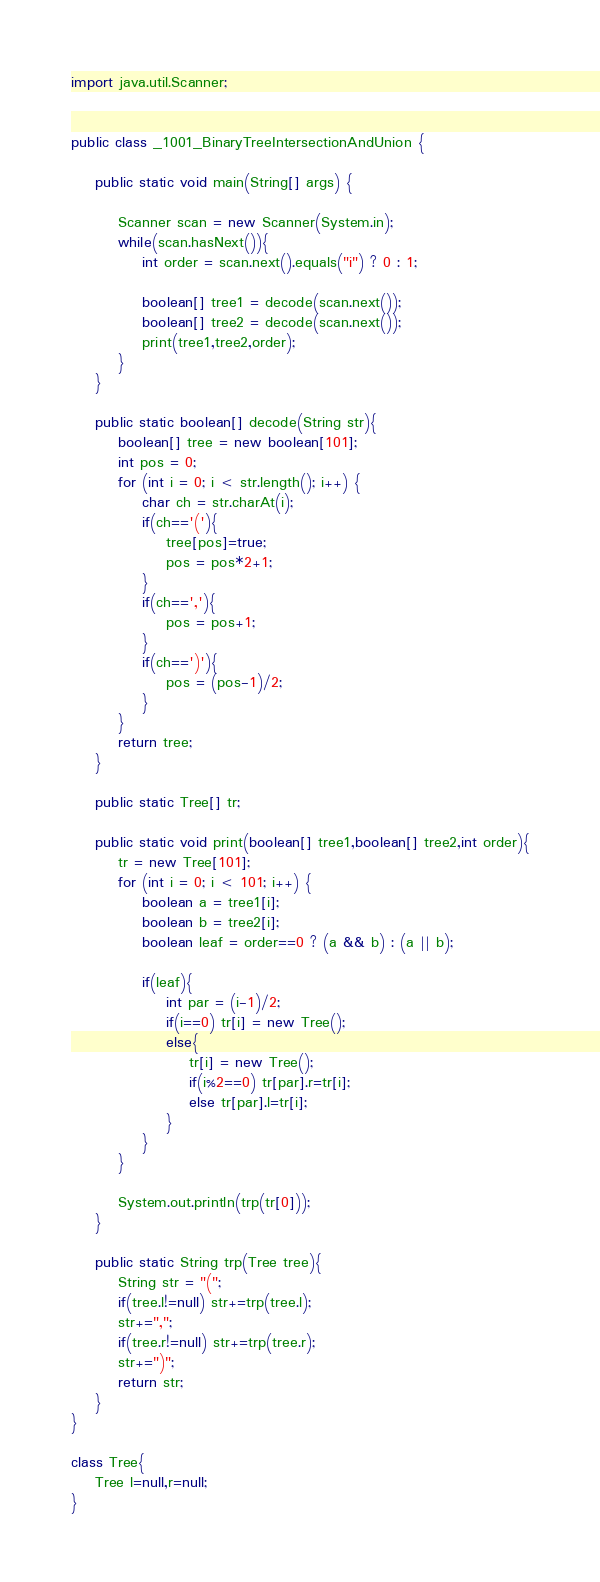Convert code to text. <code><loc_0><loc_0><loc_500><loc_500><_Java_>import java.util.Scanner;


public class _1001_BinaryTreeIntersectionAndUnion {

	public static void main(String[] args) {

		Scanner scan = new Scanner(System.in);
		while(scan.hasNext()){
			int order = scan.next().equals("i") ? 0 : 1;

			boolean[] tree1 = decode(scan.next());
			boolean[] tree2 = decode(scan.next());
			print(tree1,tree2,order);
		}
	}

	public static boolean[] decode(String str){
		boolean[] tree = new boolean[101];
		int pos = 0;
		for (int i = 0; i < str.length(); i++) {
			char ch = str.charAt(i);
			if(ch=='('){
				tree[pos]=true;
				pos = pos*2+1;
			}
			if(ch==','){
				pos = pos+1;
			}
			if(ch==')'){
				pos = (pos-1)/2;
			}
		}
		return tree;
	}

	public static Tree[] tr;

	public static void print(boolean[] tree1,boolean[] tree2,int order){
		tr = new Tree[101];
		for (int i = 0; i < 101; i++) {
			boolean a = tree1[i];
			boolean b = tree2[i];
			boolean leaf = order==0 ? (a && b) : (a || b);

			if(leaf){
				int par = (i-1)/2;
				if(i==0) tr[i] = new Tree();
				else{
					tr[i] = new Tree();
					if(i%2==0) tr[par].r=tr[i];
					else tr[par].l=tr[i];
				}
			}
		}

		System.out.println(trp(tr[0]));
	}

	public static String trp(Tree tree){
		String str = "(";
		if(tree.l!=null) str+=trp(tree.l);
		str+=",";
		if(tree.r!=null) str+=trp(tree.r);
		str+=")";
		return str;
	}
}

class Tree{
	Tree l=null,r=null;
}</code> 